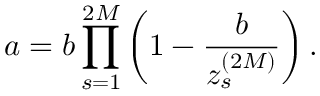<formula> <loc_0><loc_0><loc_500><loc_500>a = b \prod _ { s = 1 } ^ { 2 M } \left ( 1 - \frac { b } { z _ { s } ^ { ( 2 M ) } } \right ) .</formula> 